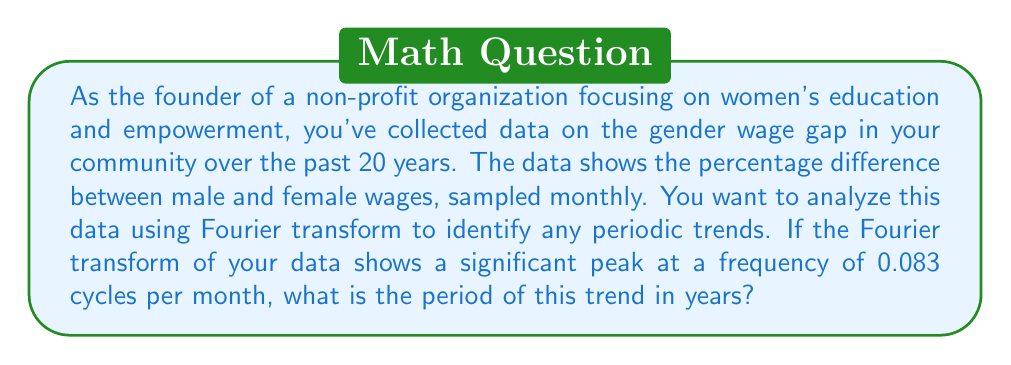Show me your answer to this math problem. To solve this problem, we need to follow these steps:

1. Understand the given frequency:
   The peak is at 0.083 cycles per month.

2. Calculate the period in months:
   Period = 1 / Frequency
   $$ T_{months} = \frac{1}{0.083} \approx 12.048 \text{ months} $$

3. Convert the period from months to years:
   $$ T_{years} = \frac{T_{months}}{12} = \frac{12.048}{12} \approx 1.004 \text{ years} $$

The Fourier transform helps identify periodic components in the data. A peak in the transform indicates a strong periodic trend at that frequency. In this case, the peak at 0.083 cycles per month suggests a cycle that repeats approximately every 12 months, or 1 year.

This annual cycle could be related to various factors affecting the gender wage gap, such as:
- Annual salary reviews and adjustments
- Seasonal employment patterns that may affect men and women differently
- Yearly budget allocations in companies or sectors

As the leader of a women's empowerment organization, recognizing this annual trend can help you target your efforts more effectively, perhaps by advocating for policy changes or educational programs that address these yearly fluctuations in the gender wage gap.
Answer: The period of the trend is approximately 1.004 years. 